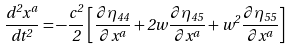<formula> <loc_0><loc_0><loc_500><loc_500>\frac { d ^ { 2 } x ^ { a } } { d t ^ { 2 } } = - \frac { c ^ { 2 } } { 2 } \left [ \frac { \partial \eta _ { 4 4 } } { \partial x ^ { a } } + 2 w \frac { \partial \eta _ { 4 5 } } { \partial x ^ { a } } + w ^ { 2 } \frac { \partial \eta _ { 5 5 } } { \partial x ^ { a } } \right ]</formula> 